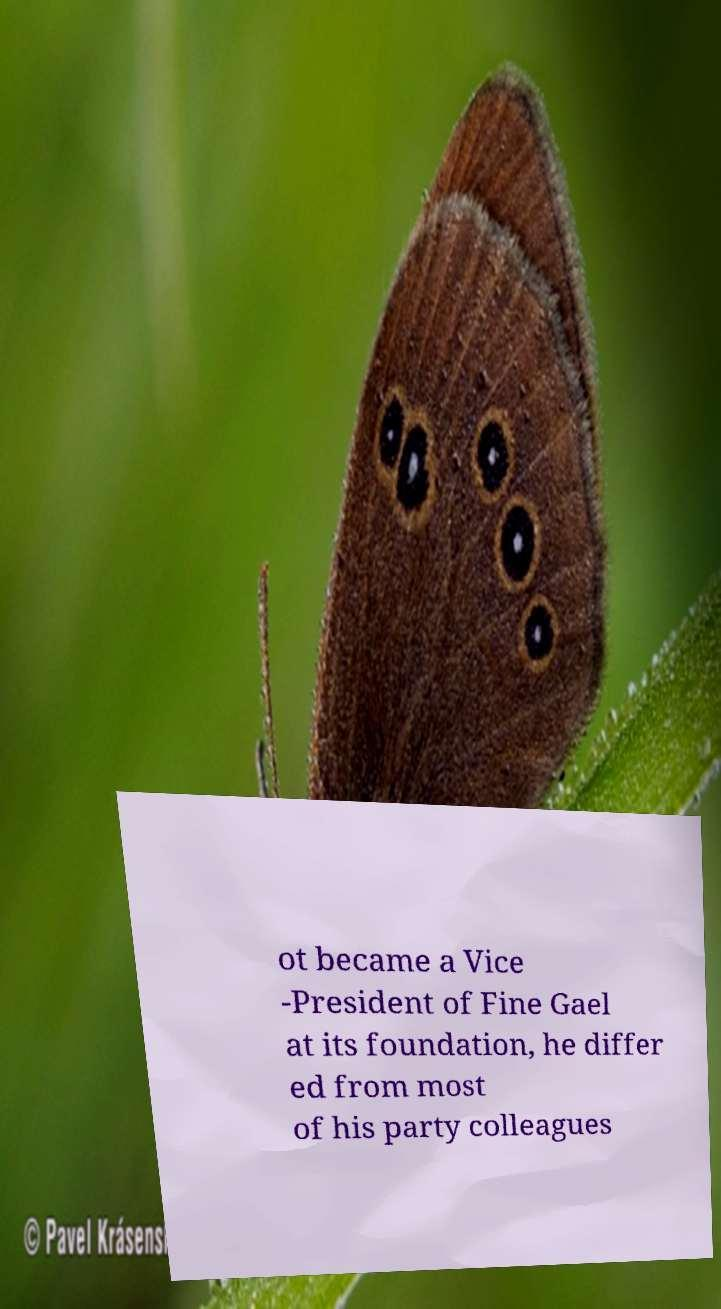What messages or text are displayed in this image? I need them in a readable, typed format. ot became a Vice -President of Fine Gael at its foundation, he differ ed from most of his party colleagues 